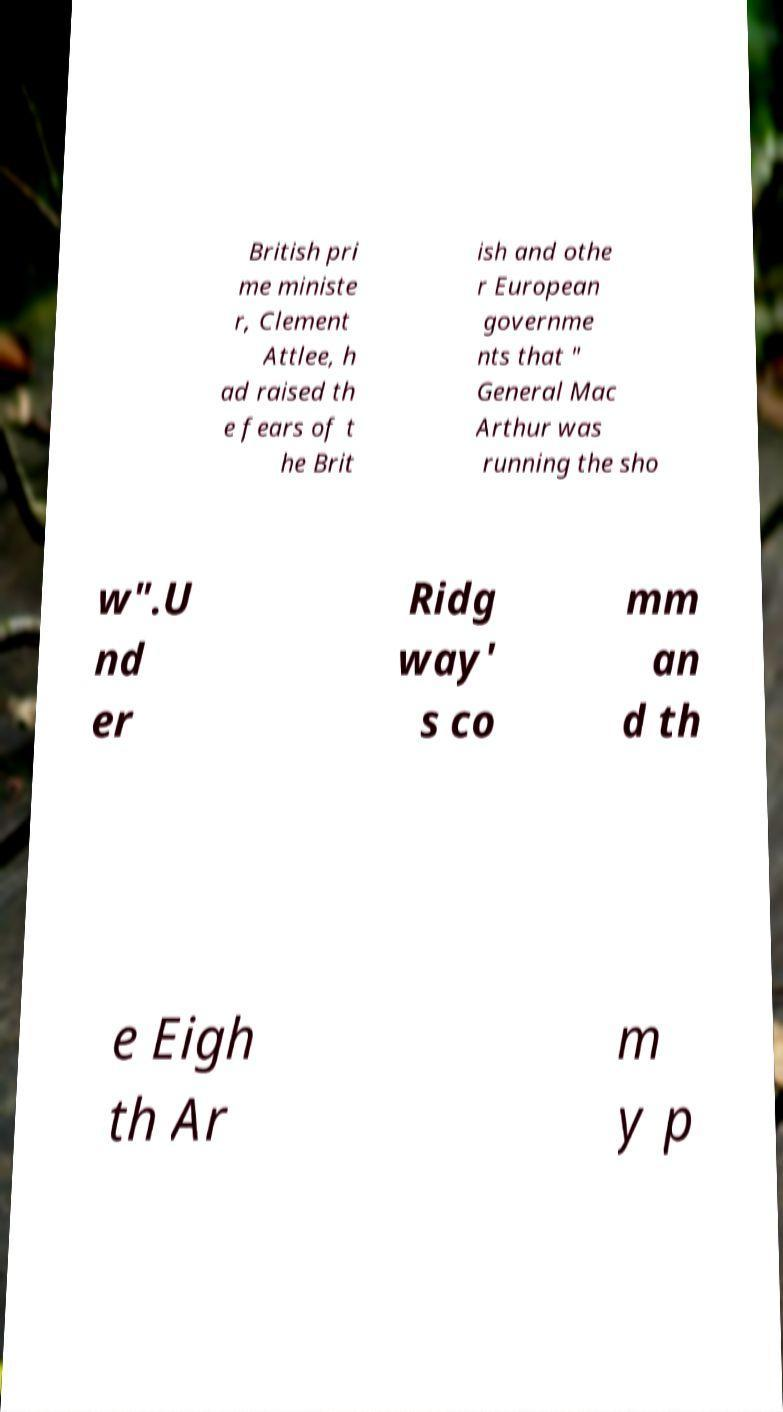Please identify and transcribe the text found in this image. British pri me ministe r, Clement Attlee, h ad raised th e fears of t he Brit ish and othe r European governme nts that " General Mac Arthur was running the sho w".U nd er Ridg way' s co mm an d th e Eigh th Ar m y p 